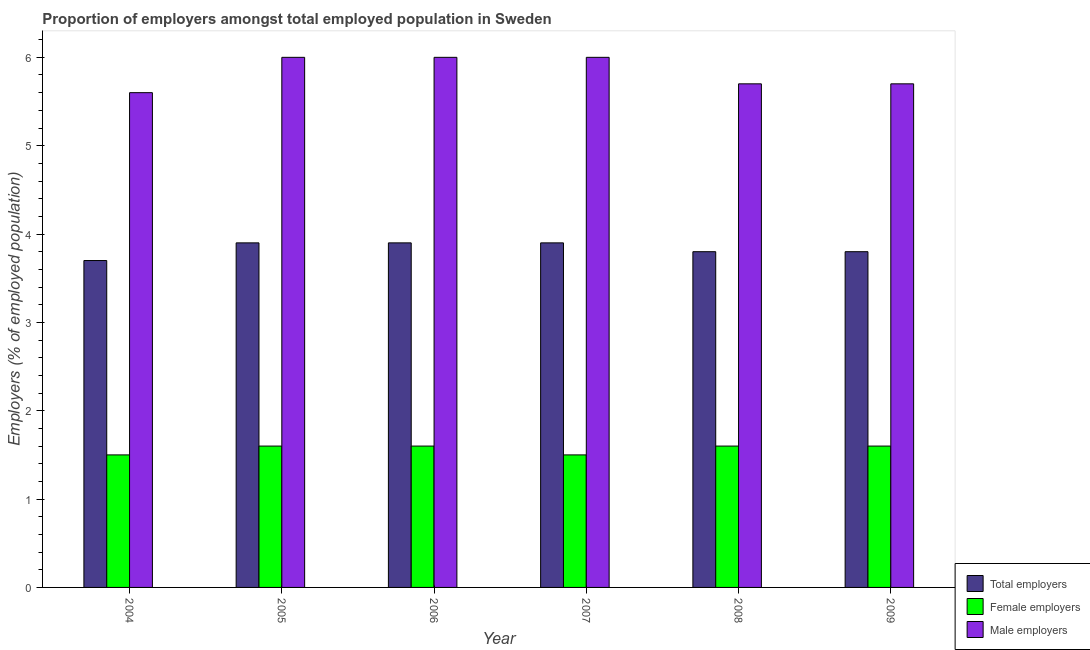Are the number of bars on each tick of the X-axis equal?
Ensure brevity in your answer.  Yes. How many bars are there on the 3rd tick from the right?
Keep it short and to the point. 3. What is the label of the 6th group of bars from the left?
Give a very brief answer. 2009. Across all years, what is the maximum percentage of total employers?
Your answer should be very brief. 3.9. Across all years, what is the minimum percentage of total employers?
Provide a succinct answer. 3.7. In which year was the percentage of male employers maximum?
Give a very brief answer. 2005. In which year was the percentage of female employers minimum?
Offer a very short reply. 2004. What is the total percentage of male employers in the graph?
Give a very brief answer. 35. What is the difference between the percentage of male employers in 2004 and that in 2005?
Provide a short and direct response. -0.4. What is the difference between the percentage of female employers in 2007 and the percentage of male employers in 2006?
Ensure brevity in your answer.  -0.1. What is the average percentage of total employers per year?
Provide a short and direct response. 3.83. In the year 2008, what is the difference between the percentage of female employers and percentage of male employers?
Ensure brevity in your answer.  0. Is the percentage of male employers in 2004 less than that in 2008?
Give a very brief answer. Yes. What is the difference between the highest and the lowest percentage of male employers?
Offer a very short reply. 0.4. Is the sum of the percentage of female employers in 2008 and 2009 greater than the maximum percentage of male employers across all years?
Offer a very short reply. Yes. What does the 2nd bar from the left in 2009 represents?
Provide a short and direct response. Female employers. What does the 3rd bar from the right in 2006 represents?
Your response must be concise. Total employers. Is it the case that in every year, the sum of the percentage of total employers and percentage of female employers is greater than the percentage of male employers?
Offer a very short reply. No. Are all the bars in the graph horizontal?
Provide a short and direct response. No. Does the graph contain grids?
Ensure brevity in your answer.  No. How many legend labels are there?
Give a very brief answer. 3. How are the legend labels stacked?
Keep it short and to the point. Vertical. What is the title of the graph?
Offer a terse response. Proportion of employers amongst total employed population in Sweden. Does "Services" appear as one of the legend labels in the graph?
Make the answer very short. No. What is the label or title of the Y-axis?
Your answer should be very brief. Employers (% of employed population). What is the Employers (% of employed population) in Total employers in 2004?
Your response must be concise. 3.7. What is the Employers (% of employed population) in Male employers in 2004?
Your response must be concise. 5.6. What is the Employers (% of employed population) in Total employers in 2005?
Provide a succinct answer. 3.9. What is the Employers (% of employed population) in Female employers in 2005?
Offer a very short reply. 1.6. What is the Employers (% of employed population) of Male employers in 2005?
Offer a very short reply. 6. What is the Employers (% of employed population) of Total employers in 2006?
Ensure brevity in your answer.  3.9. What is the Employers (% of employed population) of Female employers in 2006?
Your answer should be very brief. 1.6. What is the Employers (% of employed population) in Male employers in 2006?
Your response must be concise. 6. What is the Employers (% of employed population) in Total employers in 2007?
Provide a short and direct response. 3.9. What is the Employers (% of employed population) in Total employers in 2008?
Keep it short and to the point. 3.8. What is the Employers (% of employed population) of Female employers in 2008?
Make the answer very short. 1.6. What is the Employers (% of employed population) in Male employers in 2008?
Provide a succinct answer. 5.7. What is the Employers (% of employed population) in Total employers in 2009?
Give a very brief answer. 3.8. What is the Employers (% of employed population) of Female employers in 2009?
Your answer should be very brief. 1.6. What is the Employers (% of employed population) in Male employers in 2009?
Offer a terse response. 5.7. Across all years, what is the maximum Employers (% of employed population) of Total employers?
Provide a succinct answer. 3.9. Across all years, what is the maximum Employers (% of employed population) in Female employers?
Your answer should be compact. 1.6. Across all years, what is the maximum Employers (% of employed population) of Male employers?
Make the answer very short. 6. Across all years, what is the minimum Employers (% of employed population) in Total employers?
Make the answer very short. 3.7. Across all years, what is the minimum Employers (% of employed population) in Female employers?
Provide a succinct answer. 1.5. Across all years, what is the minimum Employers (% of employed population) in Male employers?
Offer a terse response. 5.6. What is the difference between the Employers (% of employed population) in Total employers in 2004 and that in 2005?
Provide a succinct answer. -0.2. What is the difference between the Employers (% of employed population) in Female employers in 2004 and that in 2005?
Offer a very short reply. -0.1. What is the difference between the Employers (% of employed population) in Total employers in 2004 and that in 2006?
Your answer should be very brief. -0.2. What is the difference between the Employers (% of employed population) of Female employers in 2004 and that in 2006?
Your answer should be compact. -0.1. What is the difference between the Employers (% of employed population) of Total employers in 2004 and that in 2007?
Your response must be concise. -0.2. What is the difference between the Employers (% of employed population) in Female employers in 2004 and that in 2007?
Your response must be concise. 0. What is the difference between the Employers (% of employed population) in Female employers in 2004 and that in 2008?
Offer a terse response. -0.1. What is the difference between the Employers (% of employed population) of Male employers in 2004 and that in 2008?
Provide a short and direct response. -0.1. What is the difference between the Employers (% of employed population) in Total employers in 2004 and that in 2009?
Provide a short and direct response. -0.1. What is the difference between the Employers (% of employed population) of Female employers in 2004 and that in 2009?
Your answer should be very brief. -0.1. What is the difference between the Employers (% of employed population) of Male employers in 2004 and that in 2009?
Your answer should be compact. -0.1. What is the difference between the Employers (% of employed population) of Total employers in 2005 and that in 2006?
Your response must be concise. 0. What is the difference between the Employers (% of employed population) of Male employers in 2005 and that in 2006?
Your answer should be very brief. 0. What is the difference between the Employers (% of employed population) in Female employers in 2005 and that in 2007?
Ensure brevity in your answer.  0.1. What is the difference between the Employers (% of employed population) of Total employers in 2005 and that in 2008?
Offer a very short reply. 0.1. What is the difference between the Employers (% of employed population) of Total employers in 2005 and that in 2009?
Your response must be concise. 0.1. What is the difference between the Employers (% of employed population) of Male employers in 2005 and that in 2009?
Your response must be concise. 0.3. What is the difference between the Employers (% of employed population) in Total employers in 2006 and that in 2007?
Your answer should be compact. 0. What is the difference between the Employers (% of employed population) of Female employers in 2006 and that in 2007?
Your response must be concise. 0.1. What is the difference between the Employers (% of employed population) in Total employers in 2006 and that in 2009?
Give a very brief answer. 0.1. What is the difference between the Employers (% of employed population) in Male employers in 2006 and that in 2009?
Provide a short and direct response. 0.3. What is the difference between the Employers (% of employed population) in Male employers in 2007 and that in 2008?
Your answer should be compact. 0.3. What is the difference between the Employers (% of employed population) of Total employers in 2007 and that in 2009?
Ensure brevity in your answer.  0.1. What is the difference between the Employers (% of employed population) of Female employers in 2007 and that in 2009?
Give a very brief answer. -0.1. What is the difference between the Employers (% of employed population) in Male employers in 2007 and that in 2009?
Offer a terse response. 0.3. What is the difference between the Employers (% of employed population) in Total employers in 2008 and that in 2009?
Make the answer very short. 0. What is the difference between the Employers (% of employed population) in Total employers in 2004 and the Employers (% of employed population) in Female employers in 2005?
Offer a very short reply. 2.1. What is the difference between the Employers (% of employed population) of Total employers in 2004 and the Employers (% of employed population) of Male employers in 2006?
Your answer should be very brief. -2.3. What is the difference between the Employers (% of employed population) of Female employers in 2004 and the Employers (% of employed population) of Male employers in 2006?
Make the answer very short. -4.5. What is the difference between the Employers (% of employed population) in Total employers in 2004 and the Employers (% of employed population) in Female employers in 2007?
Offer a terse response. 2.2. What is the difference between the Employers (% of employed population) in Female employers in 2004 and the Employers (% of employed population) in Male employers in 2007?
Your response must be concise. -4.5. What is the difference between the Employers (% of employed population) in Total employers in 2004 and the Employers (% of employed population) in Female employers in 2008?
Keep it short and to the point. 2.1. What is the difference between the Employers (% of employed population) of Female employers in 2004 and the Employers (% of employed population) of Male employers in 2008?
Your response must be concise. -4.2. What is the difference between the Employers (% of employed population) of Total employers in 2004 and the Employers (% of employed population) of Male employers in 2009?
Provide a short and direct response. -2. What is the difference between the Employers (% of employed population) in Female employers in 2004 and the Employers (% of employed population) in Male employers in 2009?
Give a very brief answer. -4.2. What is the difference between the Employers (% of employed population) in Total employers in 2005 and the Employers (% of employed population) in Male employers in 2006?
Provide a succinct answer. -2.1. What is the difference between the Employers (% of employed population) in Female employers in 2005 and the Employers (% of employed population) in Male employers in 2006?
Your answer should be very brief. -4.4. What is the difference between the Employers (% of employed population) in Total employers in 2005 and the Employers (% of employed population) in Female employers in 2007?
Keep it short and to the point. 2.4. What is the difference between the Employers (% of employed population) in Total employers in 2005 and the Employers (% of employed population) in Male employers in 2007?
Keep it short and to the point. -2.1. What is the difference between the Employers (% of employed population) in Total employers in 2005 and the Employers (% of employed population) in Female employers in 2008?
Your answer should be compact. 2.3. What is the difference between the Employers (% of employed population) of Female employers in 2005 and the Employers (% of employed population) of Male employers in 2008?
Make the answer very short. -4.1. What is the difference between the Employers (% of employed population) in Total employers in 2005 and the Employers (% of employed population) in Female employers in 2009?
Your answer should be very brief. 2.3. What is the difference between the Employers (% of employed population) of Total employers in 2005 and the Employers (% of employed population) of Male employers in 2009?
Offer a very short reply. -1.8. What is the difference between the Employers (% of employed population) of Total employers in 2006 and the Employers (% of employed population) of Male employers in 2007?
Provide a succinct answer. -2.1. What is the difference between the Employers (% of employed population) of Total employers in 2006 and the Employers (% of employed population) of Female employers in 2008?
Provide a succinct answer. 2.3. What is the difference between the Employers (% of employed population) of Female employers in 2006 and the Employers (% of employed population) of Male employers in 2008?
Your answer should be compact. -4.1. What is the difference between the Employers (% of employed population) in Female employers in 2006 and the Employers (% of employed population) in Male employers in 2009?
Provide a succinct answer. -4.1. What is the difference between the Employers (% of employed population) of Total employers in 2007 and the Employers (% of employed population) of Female employers in 2008?
Provide a succinct answer. 2.3. What is the difference between the Employers (% of employed population) in Female employers in 2007 and the Employers (% of employed population) in Male employers in 2008?
Ensure brevity in your answer.  -4.2. What is the difference between the Employers (% of employed population) in Female employers in 2007 and the Employers (% of employed population) in Male employers in 2009?
Your answer should be very brief. -4.2. What is the difference between the Employers (% of employed population) in Total employers in 2008 and the Employers (% of employed population) in Male employers in 2009?
Offer a very short reply. -1.9. What is the difference between the Employers (% of employed population) in Female employers in 2008 and the Employers (% of employed population) in Male employers in 2009?
Ensure brevity in your answer.  -4.1. What is the average Employers (% of employed population) of Total employers per year?
Keep it short and to the point. 3.83. What is the average Employers (% of employed population) in Female employers per year?
Offer a terse response. 1.57. What is the average Employers (% of employed population) of Male employers per year?
Your answer should be very brief. 5.83. In the year 2004, what is the difference between the Employers (% of employed population) of Total employers and Employers (% of employed population) of Female employers?
Make the answer very short. 2.2. In the year 2005, what is the difference between the Employers (% of employed population) in Female employers and Employers (% of employed population) in Male employers?
Offer a very short reply. -4.4. In the year 2006, what is the difference between the Employers (% of employed population) of Female employers and Employers (% of employed population) of Male employers?
Provide a succinct answer. -4.4. In the year 2007, what is the difference between the Employers (% of employed population) of Total employers and Employers (% of employed population) of Male employers?
Your response must be concise. -2.1. In the year 2007, what is the difference between the Employers (% of employed population) in Female employers and Employers (% of employed population) in Male employers?
Provide a short and direct response. -4.5. In the year 2008, what is the difference between the Employers (% of employed population) of Female employers and Employers (% of employed population) of Male employers?
Give a very brief answer. -4.1. In the year 2009, what is the difference between the Employers (% of employed population) of Total employers and Employers (% of employed population) of Female employers?
Provide a succinct answer. 2.2. In the year 2009, what is the difference between the Employers (% of employed population) of Total employers and Employers (% of employed population) of Male employers?
Provide a short and direct response. -1.9. In the year 2009, what is the difference between the Employers (% of employed population) of Female employers and Employers (% of employed population) of Male employers?
Make the answer very short. -4.1. What is the ratio of the Employers (% of employed population) of Total employers in 2004 to that in 2005?
Give a very brief answer. 0.95. What is the ratio of the Employers (% of employed population) of Male employers in 2004 to that in 2005?
Provide a succinct answer. 0.93. What is the ratio of the Employers (% of employed population) in Total employers in 2004 to that in 2006?
Keep it short and to the point. 0.95. What is the ratio of the Employers (% of employed population) of Total employers in 2004 to that in 2007?
Make the answer very short. 0.95. What is the ratio of the Employers (% of employed population) of Male employers in 2004 to that in 2007?
Make the answer very short. 0.93. What is the ratio of the Employers (% of employed population) of Total employers in 2004 to that in 2008?
Keep it short and to the point. 0.97. What is the ratio of the Employers (% of employed population) in Female employers in 2004 to that in 2008?
Offer a very short reply. 0.94. What is the ratio of the Employers (% of employed population) of Male employers in 2004 to that in 2008?
Give a very brief answer. 0.98. What is the ratio of the Employers (% of employed population) of Total employers in 2004 to that in 2009?
Your response must be concise. 0.97. What is the ratio of the Employers (% of employed population) in Male employers in 2004 to that in 2009?
Provide a succinct answer. 0.98. What is the ratio of the Employers (% of employed population) of Total employers in 2005 to that in 2006?
Ensure brevity in your answer.  1. What is the ratio of the Employers (% of employed population) of Female employers in 2005 to that in 2006?
Give a very brief answer. 1. What is the ratio of the Employers (% of employed population) in Male employers in 2005 to that in 2006?
Your response must be concise. 1. What is the ratio of the Employers (% of employed population) of Total employers in 2005 to that in 2007?
Your answer should be very brief. 1. What is the ratio of the Employers (% of employed population) of Female employers in 2005 to that in 2007?
Provide a succinct answer. 1.07. What is the ratio of the Employers (% of employed population) in Male employers in 2005 to that in 2007?
Offer a very short reply. 1. What is the ratio of the Employers (% of employed population) of Total employers in 2005 to that in 2008?
Provide a short and direct response. 1.03. What is the ratio of the Employers (% of employed population) of Male employers in 2005 to that in 2008?
Your answer should be compact. 1.05. What is the ratio of the Employers (% of employed population) of Total employers in 2005 to that in 2009?
Your answer should be compact. 1.03. What is the ratio of the Employers (% of employed population) of Female employers in 2005 to that in 2009?
Provide a short and direct response. 1. What is the ratio of the Employers (% of employed population) of Male employers in 2005 to that in 2009?
Ensure brevity in your answer.  1.05. What is the ratio of the Employers (% of employed population) in Female employers in 2006 to that in 2007?
Provide a succinct answer. 1.07. What is the ratio of the Employers (% of employed population) of Male employers in 2006 to that in 2007?
Your answer should be compact. 1. What is the ratio of the Employers (% of employed population) of Total employers in 2006 to that in 2008?
Keep it short and to the point. 1.03. What is the ratio of the Employers (% of employed population) of Female employers in 2006 to that in 2008?
Make the answer very short. 1. What is the ratio of the Employers (% of employed population) in Male employers in 2006 to that in 2008?
Make the answer very short. 1.05. What is the ratio of the Employers (% of employed population) of Total employers in 2006 to that in 2009?
Offer a very short reply. 1.03. What is the ratio of the Employers (% of employed population) in Male employers in 2006 to that in 2009?
Provide a short and direct response. 1.05. What is the ratio of the Employers (% of employed population) in Total employers in 2007 to that in 2008?
Offer a very short reply. 1.03. What is the ratio of the Employers (% of employed population) in Male employers in 2007 to that in 2008?
Give a very brief answer. 1.05. What is the ratio of the Employers (% of employed population) in Total employers in 2007 to that in 2009?
Keep it short and to the point. 1.03. What is the ratio of the Employers (% of employed population) in Female employers in 2007 to that in 2009?
Provide a succinct answer. 0.94. What is the ratio of the Employers (% of employed population) in Male employers in 2007 to that in 2009?
Give a very brief answer. 1.05. What is the difference between the highest and the second highest Employers (% of employed population) of Male employers?
Your answer should be compact. 0. What is the difference between the highest and the lowest Employers (% of employed population) in Total employers?
Ensure brevity in your answer.  0.2. What is the difference between the highest and the lowest Employers (% of employed population) of Female employers?
Your response must be concise. 0.1. What is the difference between the highest and the lowest Employers (% of employed population) of Male employers?
Offer a very short reply. 0.4. 